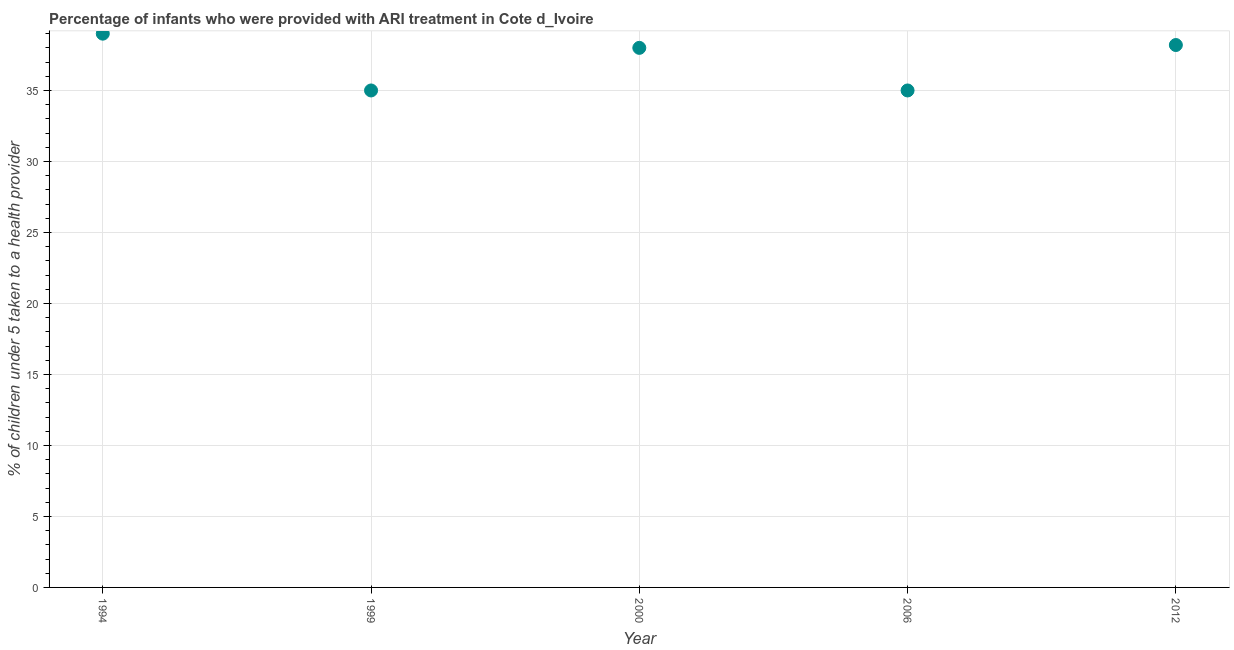What is the percentage of children who were provided with ari treatment in 2006?
Your response must be concise. 35. In which year was the percentage of children who were provided with ari treatment maximum?
Keep it short and to the point. 1994. In which year was the percentage of children who were provided with ari treatment minimum?
Give a very brief answer. 1999. What is the sum of the percentage of children who were provided with ari treatment?
Make the answer very short. 185.2. What is the difference between the percentage of children who were provided with ari treatment in 2006 and 2012?
Give a very brief answer. -3.2. What is the average percentage of children who were provided with ari treatment per year?
Your answer should be compact. 37.04. In how many years, is the percentage of children who were provided with ari treatment greater than 38 %?
Offer a very short reply. 2. Do a majority of the years between 2012 and 1999 (inclusive) have percentage of children who were provided with ari treatment greater than 2 %?
Ensure brevity in your answer.  Yes. What is the ratio of the percentage of children who were provided with ari treatment in 2000 to that in 2006?
Provide a short and direct response. 1.09. Is the difference between the percentage of children who were provided with ari treatment in 1999 and 2000 greater than the difference between any two years?
Your response must be concise. No. What is the difference between the highest and the second highest percentage of children who were provided with ari treatment?
Your answer should be very brief. 0.8. Is the sum of the percentage of children who were provided with ari treatment in 1994 and 2000 greater than the maximum percentage of children who were provided with ari treatment across all years?
Give a very brief answer. Yes. What is the difference between the highest and the lowest percentage of children who were provided with ari treatment?
Your answer should be very brief. 4. What is the difference between two consecutive major ticks on the Y-axis?
Your answer should be very brief. 5. Does the graph contain grids?
Your answer should be very brief. Yes. What is the title of the graph?
Make the answer very short. Percentage of infants who were provided with ARI treatment in Cote d_Ivoire. What is the label or title of the Y-axis?
Make the answer very short. % of children under 5 taken to a health provider. What is the % of children under 5 taken to a health provider in 2006?
Make the answer very short. 35. What is the % of children under 5 taken to a health provider in 2012?
Offer a very short reply. 38.2. What is the difference between the % of children under 5 taken to a health provider in 1994 and 2000?
Make the answer very short. 1. What is the difference between the % of children under 5 taken to a health provider in 1994 and 2012?
Provide a short and direct response. 0.8. What is the difference between the % of children under 5 taken to a health provider in 1999 and 2006?
Your response must be concise. 0. What is the difference between the % of children under 5 taken to a health provider in 2000 and 2006?
Your response must be concise. 3. What is the ratio of the % of children under 5 taken to a health provider in 1994 to that in 1999?
Offer a terse response. 1.11. What is the ratio of the % of children under 5 taken to a health provider in 1994 to that in 2006?
Offer a very short reply. 1.11. What is the ratio of the % of children under 5 taken to a health provider in 1999 to that in 2000?
Make the answer very short. 0.92. What is the ratio of the % of children under 5 taken to a health provider in 1999 to that in 2006?
Provide a short and direct response. 1. What is the ratio of the % of children under 5 taken to a health provider in 1999 to that in 2012?
Provide a succinct answer. 0.92. What is the ratio of the % of children under 5 taken to a health provider in 2000 to that in 2006?
Your answer should be very brief. 1.09. What is the ratio of the % of children under 5 taken to a health provider in 2000 to that in 2012?
Offer a terse response. 0.99. What is the ratio of the % of children under 5 taken to a health provider in 2006 to that in 2012?
Ensure brevity in your answer.  0.92. 